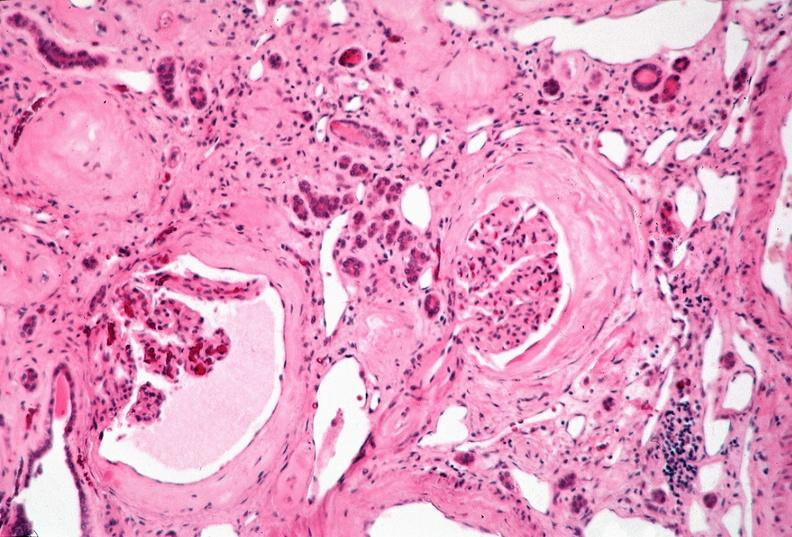where is this?
Answer the question using a single word or phrase. Urinary 